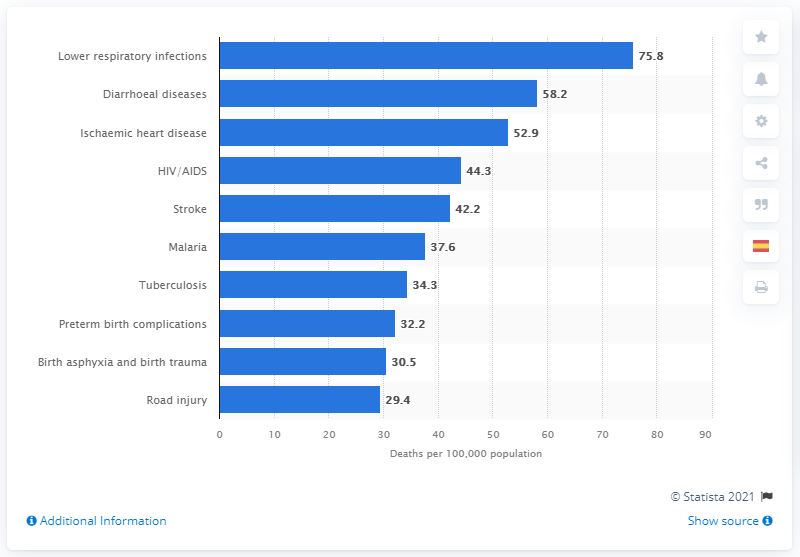Give some essential details in this illustration. The diarrheal disease death rate per 100,000 people was 58.2 The death rate from lower respiratory infections per 100,000 people was 75.8. 